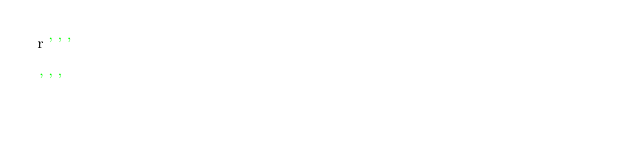Convert code to text. <code><loc_0><loc_0><loc_500><loc_500><_Python_>r'''

'''</code> 